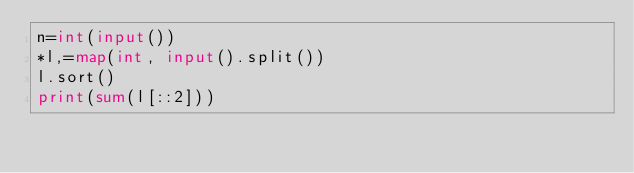<code> <loc_0><loc_0><loc_500><loc_500><_Python_>n=int(input())
*l,=map(int, input().split())
l.sort()
print(sum(l[::2]))</code> 